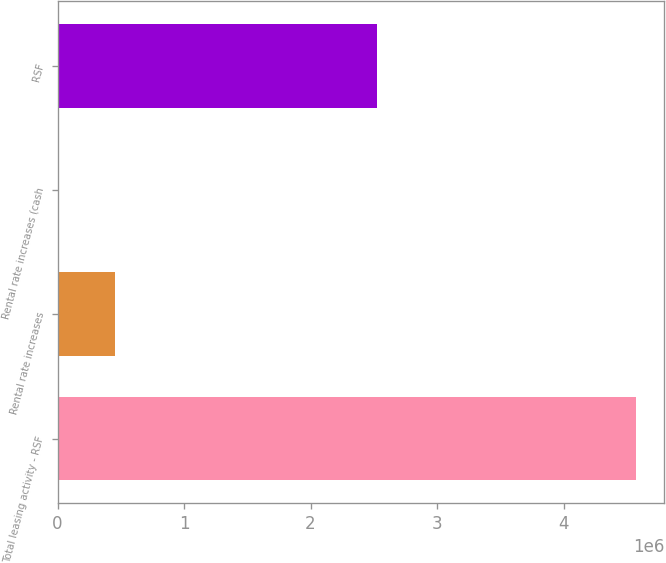Convert chart to OTSL. <chart><loc_0><loc_0><loc_500><loc_500><bar_chart><fcel>Total leasing activity - RSF<fcel>Rental rate increases<fcel>Rental rate increases (cash<fcel>RSF<nl><fcel>4.56918e+06<fcel>456930<fcel>12.7<fcel>2.5251e+06<nl></chart> 